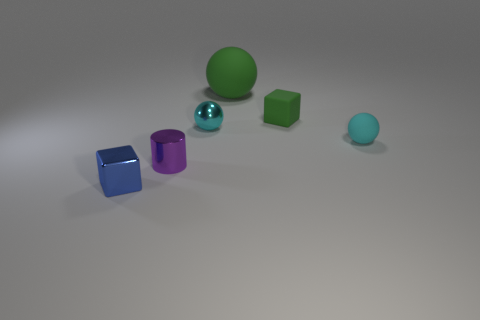Add 4 tiny rubber cubes. How many objects exist? 10 Subtract 1 spheres. How many spheres are left? 2 Subtract all cyan spheres. How many spheres are left? 1 Subtract all cubes. How many objects are left? 4 Subtract all tiny yellow blocks. Subtract all balls. How many objects are left? 3 Add 1 cyan balls. How many cyan balls are left? 3 Add 3 small gray balls. How many small gray balls exist? 3 Subtract 2 cyan spheres. How many objects are left? 4 